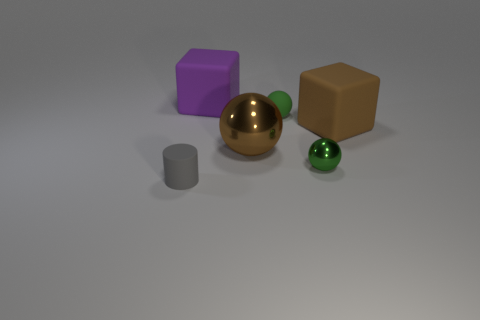Subtract all brown balls. How many balls are left? 2 Subtract all green cylinders. How many green balls are left? 2 Add 1 brown shiny objects. How many objects exist? 7 Subtract 1 spheres. How many spheres are left? 2 Subtract all purple cubes. How many cubes are left? 1 Subtract all cylinders. How many objects are left? 5 Subtract all yellow balls. Subtract all red cylinders. How many balls are left? 3 Add 4 matte cylinders. How many matte cylinders are left? 5 Add 3 big purple cubes. How many big purple cubes exist? 4 Subtract 1 brown blocks. How many objects are left? 5 